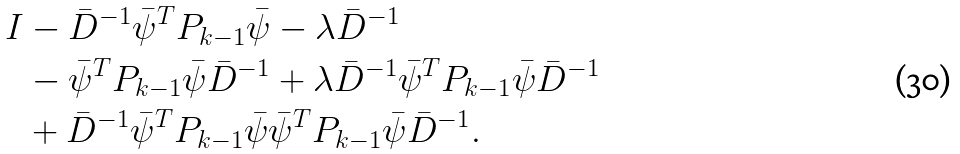<formula> <loc_0><loc_0><loc_500><loc_500>I & - \bar { D } ^ { - 1 } \bar { \psi } ^ { T } P _ { k - 1 } \bar { \psi } - \lambda \bar { D } ^ { - 1 } \\ & - \bar { \psi } ^ { T } P _ { k - 1 } \bar { \psi } \bar { D } ^ { - 1 } + \lambda \bar { D } ^ { - 1 } \bar { \psi } ^ { T } P _ { k - 1 } \bar { \psi } \bar { D } ^ { - 1 } \\ & + \bar { D } ^ { - 1 } \bar { \psi } ^ { T } P _ { k - 1 } \bar { \psi } \bar { \psi } ^ { T } P _ { k - 1 } \bar { \psi } \bar { D } ^ { - 1 } .</formula> 